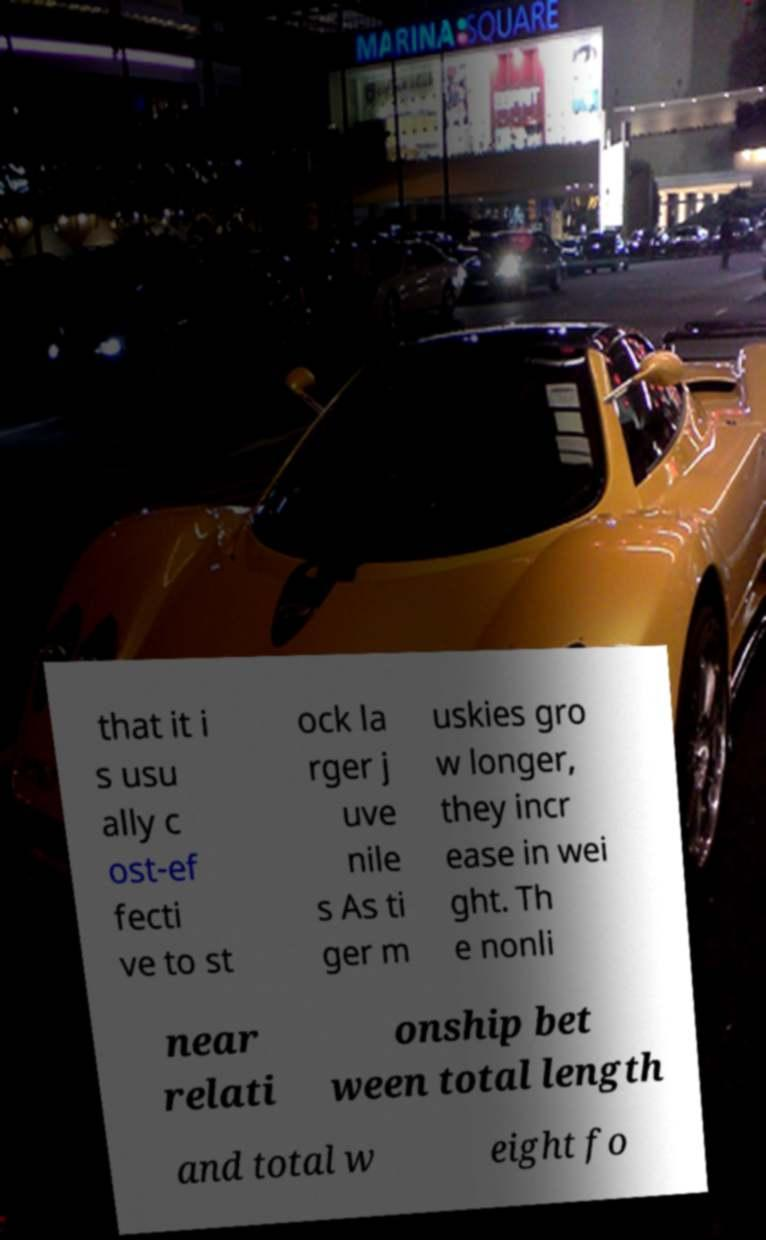Could you assist in decoding the text presented in this image and type it out clearly? that it i s usu ally c ost-ef fecti ve to st ock la rger j uve nile s As ti ger m uskies gro w longer, they incr ease in wei ght. Th e nonli near relati onship bet ween total length and total w eight fo 